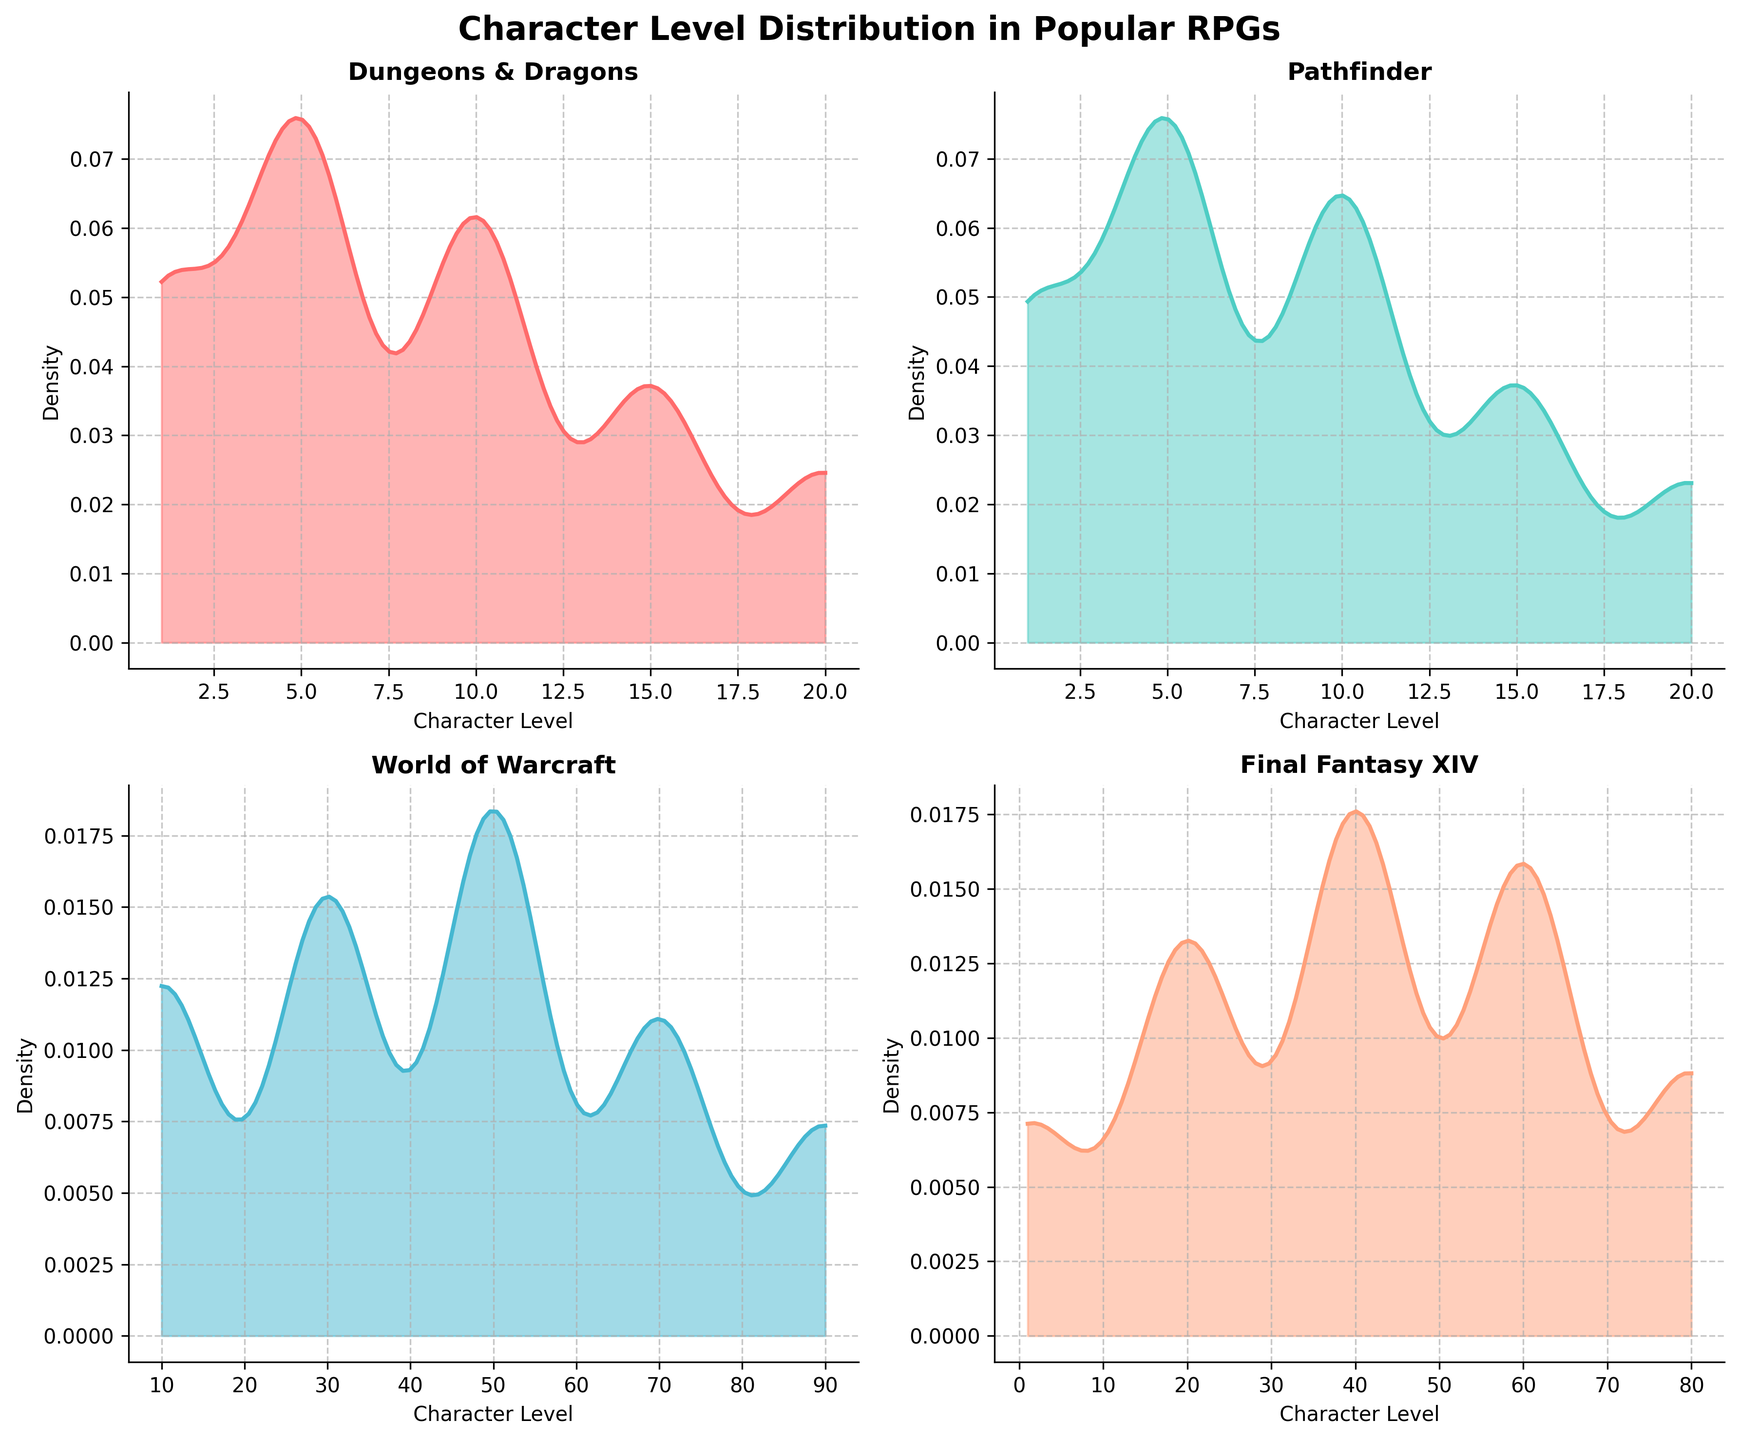What is the title of the figure? The title of the figure is located at the top and provides a summary of the data being presented. In this case, the title is "Character Level Distribution in Popular RPGs." This helps the viewer understand the overall purpose of the plots.
Answer: Character Level Distribution in Popular RPGs Which game has the highest character level density peak? The highest character level density peak is determined by observing the subplots and identifying which game has the tallest peak in its density plot.
Answer: World of Warcraft What is the color used to represent "Dungeons & Dragons"? The color representing "Dungeons & Dragons" can be identified by looking at the corresponding subplot for the game. Each game is color-coded differently.
Answer: Red How many subplots are there in the figure? The number of subplots can be counted by looking at the individual plots within the larger figure. Since the figure contains four games, it should have four subplots.
Answer: Four Which game shows the lowest density for its highest level character? By examining the density plots, we can see the density values at the highest character level for each game. The game with the lowest density at this peak level is identified.
Answer: Pathfinder Compare the character levels with the highest density in "World of Warcraft" and "Final Fantasy XIV". To do this, observe the peaks in the density plots for "World of Warcraft" and "Final Fantasy XIV" and note the character levels at these peaks. "World of Warcraft" peaks at around level 50, while "Final Fantasy XIV" peaks around level 40.
Answer: Levels 50 and 40 At what character level do both "Dungeons & Dragons" and "Pathfinder" plots intersect in the density distribution? To find this, carefully observe the density plots for both "Dungeons & Dragons" and "Pathfinder" and identify where their distributions intersect at the same density value.
Answer: Level 10 Which game displays a more uniform density distribution across its character levels? Examine each density plot to see how evenly the densities are spread across the character levels. The game with the most uniform distribution will have a relatively flat density plot.
Answer: Final Fantasy XIV Is there any game that shows a bimodal density distribution? If yes, which one? A bimodal distribution has two distinct peaks. Review each subplot to see if any game has two separate peaks in its density plot.
Answer: No Which game has the broadest range of character levels with significant density, indicating diverse character level engagement? Look for the density plot that spreads out over the most character levels with visible density peaks, indicating a broad engagement across many levels.
Answer: World of Warcraft 